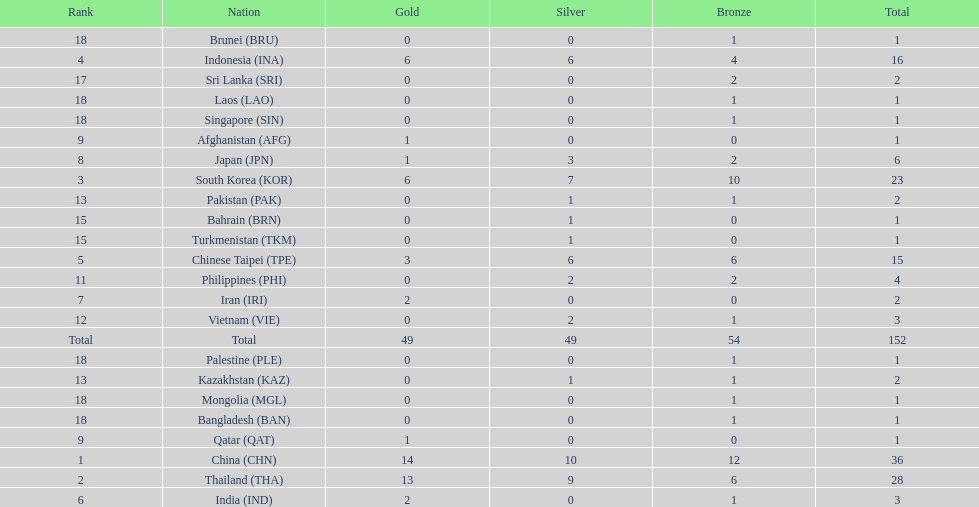How many combined silver medals did china, india, and japan earn ? 13. 